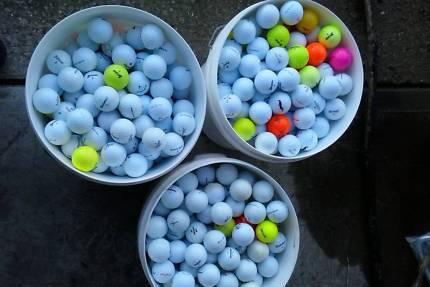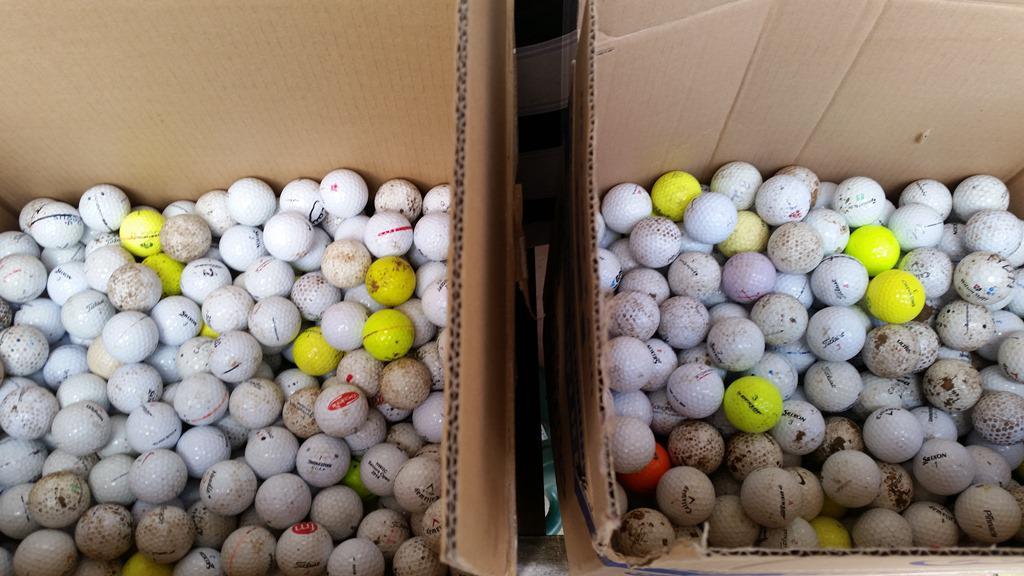The first image is the image on the left, the second image is the image on the right. Assess this claim about the two images: "There are two cardboard boxes in the image on the right.". Correct or not? Answer yes or no. Yes. The first image is the image on the left, the second image is the image on the right. Assess this claim about the two images: "One image shows a golf ball bucket with at least two bright orange balls.". Correct or not? Answer yes or no. Yes. 